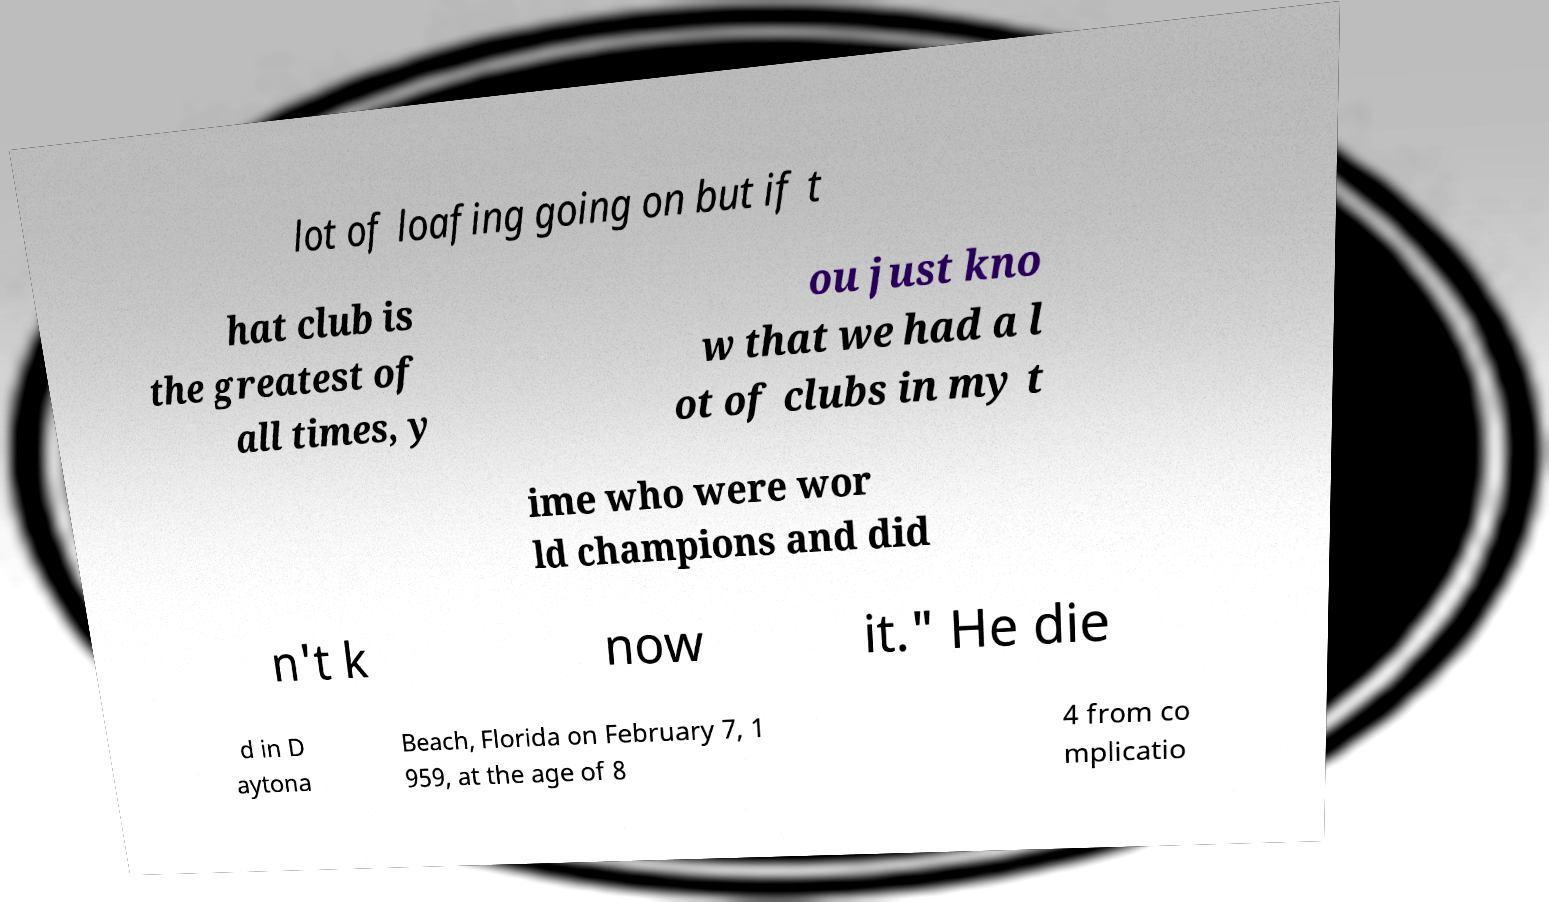Could you extract and type out the text from this image? lot of loafing going on but if t hat club is the greatest of all times, y ou just kno w that we had a l ot of clubs in my t ime who were wor ld champions and did n't k now it." He die d in D aytona Beach, Florida on February 7, 1 959, at the age of 8 4 from co mplicatio 